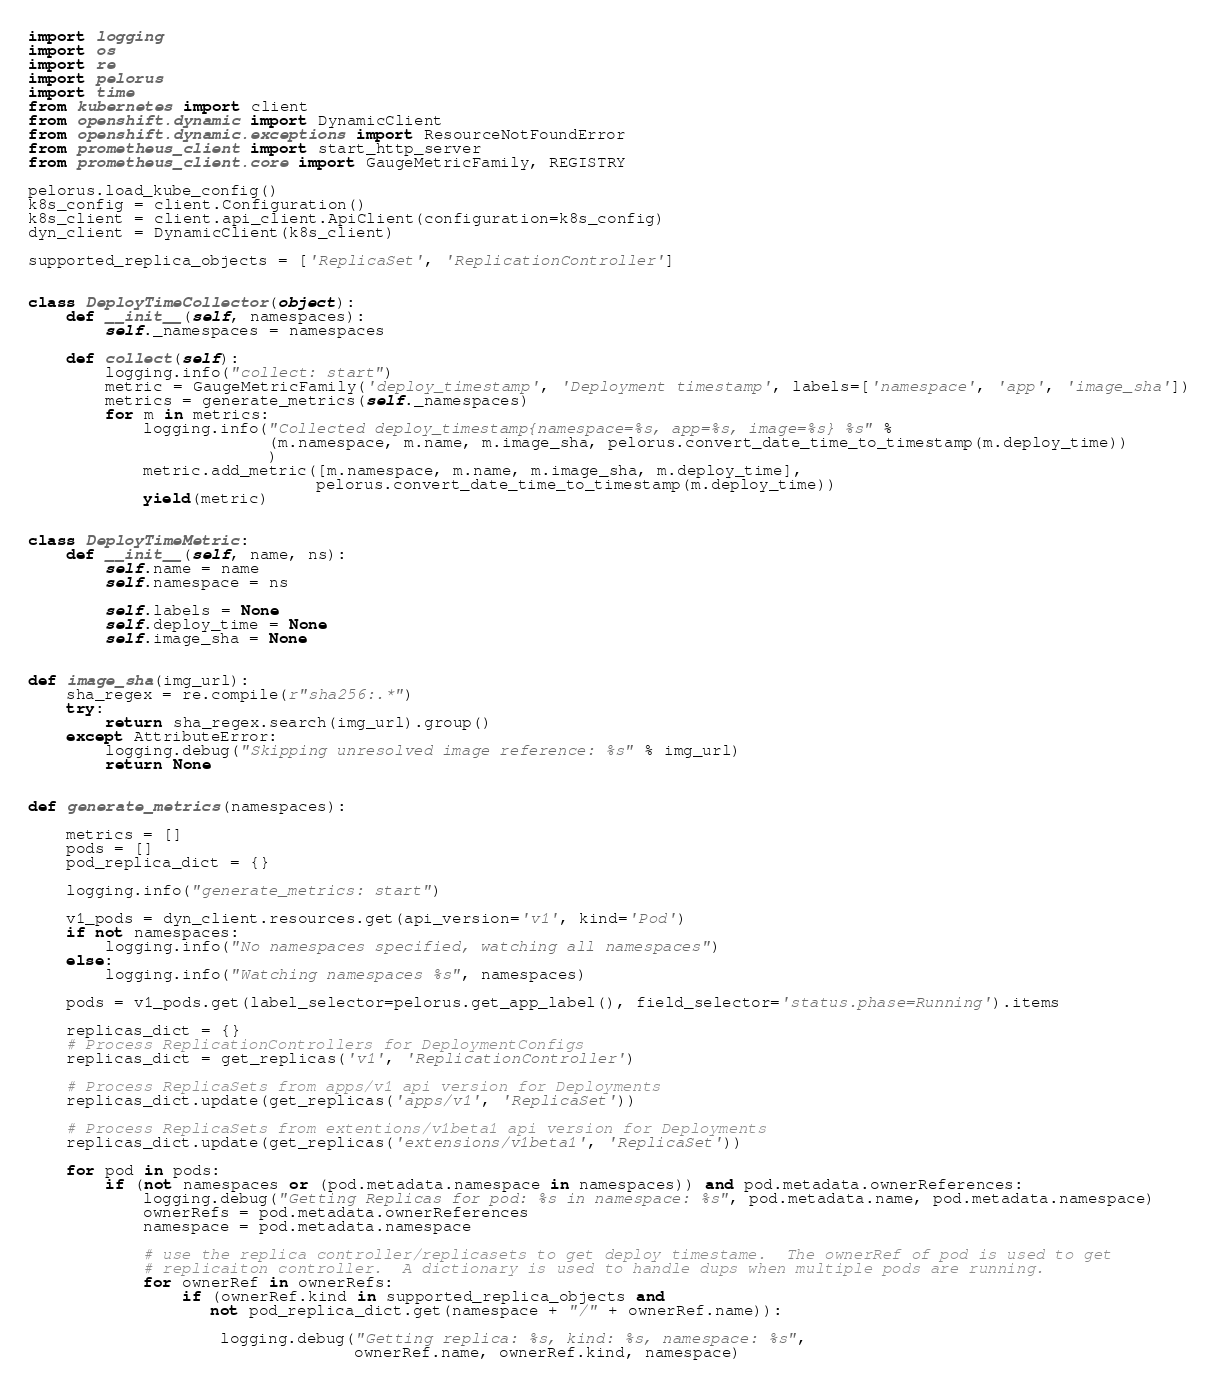Convert code to text. <code><loc_0><loc_0><loc_500><loc_500><_Python_>import logging
import os
import re
import pelorus
import time
from kubernetes import client
from openshift.dynamic import DynamicClient
from openshift.dynamic.exceptions import ResourceNotFoundError
from prometheus_client import start_http_server
from prometheus_client.core import GaugeMetricFamily, REGISTRY

pelorus.load_kube_config()
k8s_config = client.Configuration()
k8s_client = client.api_client.ApiClient(configuration=k8s_config)
dyn_client = DynamicClient(k8s_client)

supported_replica_objects = ['ReplicaSet', 'ReplicationController']


class DeployTimeCollector(object):
    def __init__(self, namespaces):
        self._namespaces = namespaces

    def collect(self):
        logging.info("collect: start")
        metric = GaugeMetricFamily('deploy_timestamp', 'Deployment timestamp', labels=['namespace', 'app', 'image_sha'])
        metrics = generate_metrics(self._namespaces)
        for m in metrics:
            logging.info("Collected deploy_timestamp{namespace=%s, app=%s, image=%s} %s" %
                         (m.namespace, m.name, m.image_sha, pelorus.convert_date_time_to_timestamp(m.deploy_time))
                         )
            metric.add_metric([m.namespace, m.name, m.image_sha, m.deploy_time],
                              pelorus.convert_date_time_to_timestamp(m.deploy_time))
            yield(metric)


class DeployTimeMetric:
    def __init__(self, name, ns):
        self.name = name
        self.namespace = ns

        self.labels = None
        self.deploy_time = None
        self.image_sha = None


def image_sha(img_url):
    sha_regex = re.compile(r"sha256:.*")
    try:
        return sha_regex.search(img_url).group()
    except AttributeError:
        logging.debug("Skipping unresolved image reference: %s" % img_url)
        return None


def generate_metrics(namespaces):

    metrics = []
    pods = []
    pod_replica_dict = {}

    logging.info("generate_metrics: start")

    v1_pods = dyn_client.resources.get(api_version='v1', kind='Pod')
    if not namespaces:
        logging.info("No namespaces specified, watching all namespaces")
    else:
        logging.info("Watching namespaces %s", namespaces)

    pods = v1_pods.get(label_selector=pelorus.get_app_label(), field_selector='status.phase=Running').items

    replicas_dict = {}
    # Process ReplicationControllers for DeploymentConfigs
    replicas_dict = get_replicas('v1', 'ReplicationController')

    # Process ReplicaSets from apps/v1 api version for Deployments
    replicas_dict.update(get_replicas('apps/v1', 'ReplicaSet'))

    # Process ReplicaSets from extentions/v1beta1 api version for Deployments
    replicas_dict.update(get_replicas('extensions/v1beta1', 'ReplicaSet'))

    for pod in pods:
        if (not namespaces or (pod.metadata.namespace in namespaces)) and pod.metadata.ownerReferences:
            logging.debug("Getting Replicas for pod: %s in namespace: %s", pod.metadata.name, pod.metadata.namespace)
            ownerRefs = pod.metadata.ownerReferences
            namespace = pod.metadata.namespace

            # use the replica controller/replicasets to get deploy timestame.  The ownerRef of pod is used to get
            # replicaiton controller.  A dictionary is used to handle dups when multiple pods are running.
            for ownerRef in ownerRefs:
                if (ownerRef.kind in supported_replica_objects and
                   not pod_replica_dict.get(namespace + "/" + ownerRef.name)):

                    logging.debug("Getting replica: %s, kind: %s, namespace: %s",
                                  ownerRef.name, ownerRef.kind, namespace)
</code> 